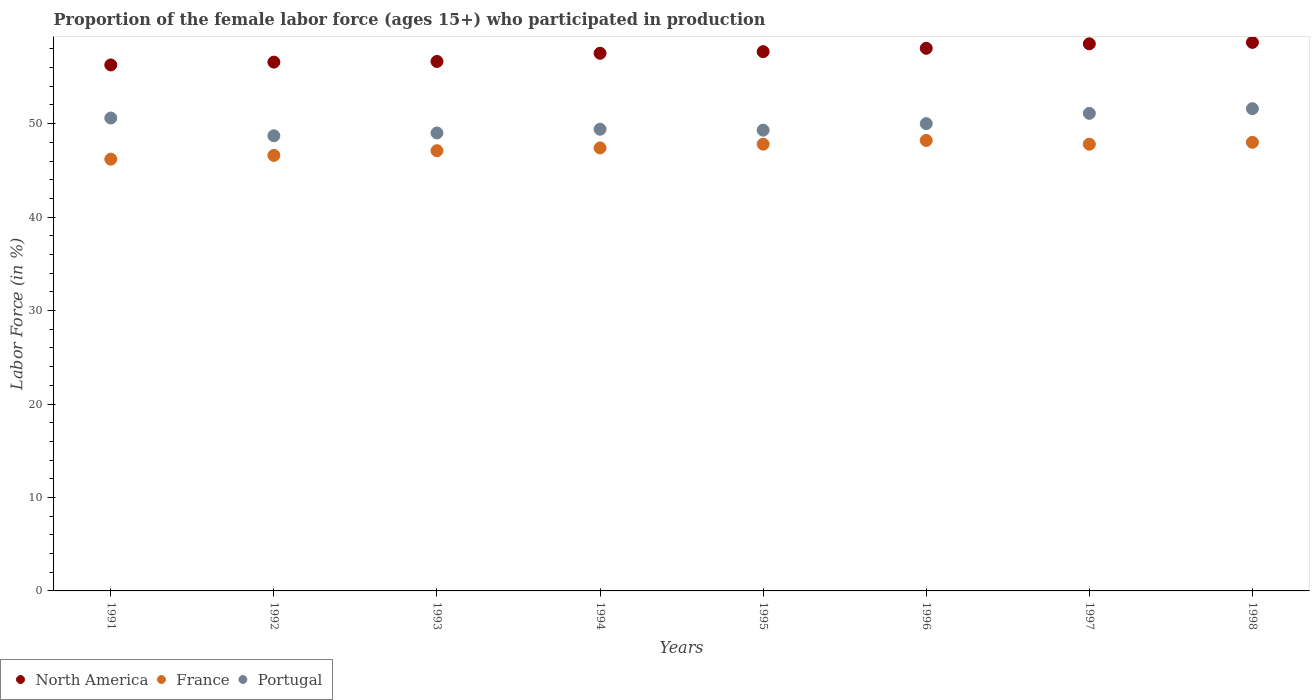How many different coloured dotlines are there?
Offer a very short reply. 3. What is the proportion of the female labor force who participated in production in Portugal in 1994?
Your response must be concise. 49.4. Across all years, what is the maximum proportion of the female labor force who participated in production in France?
Ensure brevity in your answer.  48.2. Across all years, what is the minimum proportion of the female labor force who participated in production in North America?
Your answer should be very brief. 56.28. In which year was the proportion of the female labor force who participated in production in North America maximum?
Provide a succinct answer. 1998. In which year was the proportion of the female labor force who participated in production in Portugal minimum?
Offer a terse response. 1992. What is the total proportion of the female labor force who participated in production in North America in the graph?
Provide a short and direct response. 460.03. What is the difference between the proportion of the female labor force who participated in production in Portugal in 1992 and that in 1997?
Offer a terse response. -2.4. What is the difference between the proportion of the female labor force who participated in production in Portugal in 1994 and the proportion of the female labor force who participated in production in France in 1997?
Your answer should be very brief. 1.6. What is the average proportion of the female labor force who participated in production in France per year?
Your answer should be very brief. 47.39. In the year 1997, what is the difference between the proportion of the female labor force who participated in production in North America and proportion of the female labor force who participated in production in Portugal?
Offer a very short reply. 7.44. In how many years, is the proportion of the female labor force who participated in production in North America greater than 14 %?
Your answer should be very brief. 8. What is the ratio of the proportion of the female labor force who participated in production in Portugal in 1991 to that in 1992?
Provide a short and direct response. 1.04. Is the proportion of the female labor force who participated in production in France in 1992 less than that in 1993?
Offer a terse response. Yes. What is the difference between the highest and the lowest proportion of the female labor force who participated in production in Portugal?
Give a very brief answer. 2.9. Is the sum of the proportion of the female labor force who participated in production in France in 1993 and 1997 greater than the maximum proportion of the female labor force who participated in production in Portugal across all years?
Keep it short and to the point. Yes. Is it the case that in every year, the sum of the proportion of the female labor force who participated in production in France and proportion of the female labor force who participated in production in Portugal  is greater than the proportion of the female labor force who participated in production in North America?
Offer a very short reply. Yes. Does the proportion of the female labor force who participated in production in Portugal monotonically increase over the years?
Keep it short and to the point. No. Is the proportion of the female labor force who participated in production in Portugal strictly less than the proportion of the female labor force who participated in production in France over the years?
Keep it short and to the point. No. How many dotlines are there?
Keep it short and to the point. 3. How many years are there in the graph?
Offer a terse response. 8. What is the difference between two consecutive major ticks on the Y-axis?
Keep it short and to the point. 10. Are the values on the major ticks of Y-axis written in scientific E-notation?
Make the answer very short. No. Does the graph contain any zero values?
Give a very brief answer. No. What is the title of the graph?
Offer a terse response. Proportion of the female labor force (ages 15+) who participated in production. What is the label or title of the Y-axis?
Offer a very short reply. Labor Force (in %). What is the Labor Force (in %) in North America in 1991?
Give a very brief answer. 56.28. What is the Labor Force (in %) of France in 1991?
Provide a short and direct response. 46.2. What is the Labor Force (in %) in Portugal in 1991?
Keep it short and to the point. 50.6. What is the Labor Force (in %) in North America in 1992?
Provide a short and direct response. 56.58. What is the Labor Force (in %) of France in 1992?
Keep it short and to the point. 46.6. What is the Labor Force (in %) of Portugal in 1992?
Give a very brief answer. 48.7. What is the Labor Force (in %) in North America in 1993?
Offer a terse response. 56.65. What is the Labor Force (in %) of France in 1993?
Ensure brevity in your answer.  47.1. What is the Labor Force (in %) in Portugal in 1993?
Provide a succinct answer. 49. What is the Labor Force (in %) of North America in 1994?
Offer a terse response. 57.53. What is the Labor Force (in %) in France in 1994?
Your answer should be very brief. 47.4. What is the Labor Force (in %) of Portugal in 1994?
Offer a very short reply. 49.4. What is the Labor Force (in %) of North America in 1995?
Provide a succinct answer. 57.7. What is the Labor Force (in %) in France in 1995?
Ensure brevity in your answer.  47.8. What is the Labor Force (in %) of Portugal in 1995?
Your response must be concise. 49.3. What is the Labor Force (in %) in North America in 1996?
Make the answer very short. 58.06. What is the Labor Force (in %) of France in 1996?
Give a very brief answer. 48.2. What is the Labor Force (in %) in Portugal in 1996?
Make the answer very short. 50. What is the Labor Force (in %) of North America in 1997?
Your answer should be compact. 58.54. What is the Labor Force (in %) in France in 1997?
Offer a very short reply. 47.8. What is the Labor Force (in %) in Portugal in 1997?
Give a very brief answer. 51.1. What is the Labor Force (in %) in North America in 1998?
Make the answer very short. 58.69. What is the Labor Force (in %) in Portugal in 1998?
Your answer should be very brief. 51.6. Across all years, what is the maximum Labor Force (in %) of North America?
Provide a succinct answer. 58.69. Across all years, what is the maximum Labor Force (in %) in France?
Make the answer very short. 48.2. Across all years, what is the maximum Labor Force (in %) of Portugal?
Offer a terse response. 51.6. Across all years, what is the minimum Labor Force (in %) in North America?
Give a very brief answer. 56.28. Across all years, what is the minimum Labor Force (in %) of France?
Keep it short and to the point. 46.2. Across all years, what is the minimum Labor Force (in %) in Portugal?
Offer a very short reply. 48.7. What is the total Labor Force (in %) in North America in the graph?
Provide a short and direct response. 460.03. What is the total Labor Force (in %) of France in the graph?
Offer a terse response. 379.1. What is the total Labor Force (in %) of Portugal in the graph?
Your response must be concise. 399.7. What is the difference between the Labor Force (in %) of North America in 1991 and that in 1992?
Your response must be concise. -0.3. What is the difference between the Labor Force (in %) in Portugal in 1991 and that in 1992?
Give a very brief answer. 1.9. What is the difference between the Labor Force (in %) of North America in 1991 and that in 1993?
Ensure brevity in your answer.  -0.37. What is the difference between the Labor Force (in %) in France in 1991 and that in 1993?
Make the answer very short. -0.9. What is the difference between the Labor Force (in %) in North America in 1991 and that in 1994?
Ensure brevity in your answer.  -1.25. What is the difference between the Labor Force (in %) of France in 1991 and that in 1994?
Give a very brief answer. -1.2. What is the difference between the Labor Force (in %) in Portugal in 1991 and that in 1994?
Offer a terse response. 1.2. What is the difference between the Labor Force (in %) in North America in 1991 and that in 1995?
Give a very brief answer. -1.42. What is the difference between the Labor Force (in %) of France in 1991 and that in 1995?
Provide a succinct answer. -1.6. What is the difference between the Labor Force (in %) of North America in 1991 and that in 1996?
Make the answer very short. -1.78. What is the difference between the Labor Force (in %) of France in 1991 and that in 1996?
Ensure brevity in your answer.  -2. What is the difference between the Labor Force (in %) in North America in 1991 and that in 1997?
Provide a succinct answer. -2.26. What is the difference between the Labor Force (in %) in North America in 1991 and that in 1998?
Your response must be concise. -2.41. What is the difference between the Labor Force (in %) of France in 1991 and that in 1998?
Give a very brief answer. -1.8. What is the difference between the Labor Force (in %) of North America in 1992 and that in 1993?
Make the answer very short. -0.07. What is the difference between the Labor Force (in %) of Portugal in 1992 and that in 1993?
Make the answer very short. -0.3. What is the difference between the Labor Force (in %) of North America in 1992 and that in 1994?
Offer a terse response. -0.95. What is the difference between the Labor Force (in %) of France in 1992 and that in 1994?
Keep it short and to the point. -0.8. What is the difference between the Labor Force (in %) of North America in 1992 and that in 1995?
Make the answer very short. -1.12. What is the difference between the Labor Force (in %) of France in 1992 and that in 1995?
Give a very brief answer. -1.2. What is the difference between the Labor Force (in %) in North America in 1992 and that in 1996?
Keep it short and to the point. -1.48. What is the difference between the Labor Force (in %) in France in 1992 and that in 1996?
Your answer should be very brief. -1.6. What is the difference between the Labor Force (in %) in Portugal in 1992 and that in 1996?
Ensure brevity in your answer.  -1.3. What is the difference between the Labor Force (in %) of North America in 1992 and that in 1997?
Offer a terse response. -1.96. What is the difference between the Labor Force (in %) in North America in 1992 and that in 1998?
Ensure brevity in your answer.  -2.11. What is the difference between the Labor Force (in %) in Portugal in 1992 and that in 1998?
Make the answer very short. -2.9. What is the difference between the Labor Force (in %) in North America in 1993 and that in 1994?
Offer a very short reply. -0.88. What is the difference between the Labor Force (in %) of France in 1993 and that in 1994?
Your answer should be very brief. -0.3. What is the difference between the Labor Force (in %) of North America in 1993 and that in 1995?
Your answer should be very brief. -1.05. What is the difference between the Labor Force (in %) of North America in 1993 and that in 1996?
Make the answer very short. -1.41. What is the difference between the Labor Force (in %) of Portugal in 1993 and that in 1996?
Your answer should be very brief. -1. What is the difference between the Labor Force (in %) in North America in 1993 and that in 1997?
Make the answer very short. -1.89. What is the difference between the Labor Force (in %) in France in 1993 and that in 1997?
Ensure brevity in your answer.  -0.7. What is the difference between the Labor Force (in %) of North America in 1993 and that in 1998?
Offer a very short reply. -2.04. What is the difference between the Labor Force (in %) of North America in 1994 and that in 1995?
Keep it short and to the point. -0.17. What is the difference between the Labor Force (in %) of Portugal in 1994 and that in 1995?
Provide a short and direct response. 0.1. What is the difference between the Labor Force (in %) of North America in 1994 and that in 1996?
Offer a terse response. -0.53. What is the difference between the Labor Force (in %) of France in 1994 and that in 1996?
Ensure brevity in your answer.  -0.8. What is the difference between the Labor Force (in %) of Portugal in 1994 and that in 1996?
Offer a terse response. -0.6. What is the difference between the Labor Force (in %) in North America in 1994 and that in 1997?
Your answer should be compact. -1.01. What is the difference between the Labor Force (in %) of France in 1994 and that in 1997?
Provide a short and direct response. -0.4. What is the difference between the Labor Force (in %) of Portugal in 1994 and that in 1997?
Your answer should be compact. -1.7. What is the difference between the Labor Force (in %) of North America in 1994 and that in 1998?
Your answer should be compact. -1.16. What is the difference between the Labor Force (in %) of France in 1994 and that in 1998?
Make the answer very short. -0.6. What is the difference between the Labor Force (in %) in North America in 1995 and that in 1996?
Your answer should be very brief. -0.36. What is the difference between the Labor Force (in %) of North America in 1995 and that in 1997?
Provide a short and direct response. -0.84. What is the difference between the Labor Force (in %) in France in 1995 and that in 1997?
Provide a short and direct response. 0. What is the difference between the Labor Force (in %) in Portugal in 1995 and that in 1997?
Make the answer very short. -1.8. What is the difference between the Labor Force (in %) in North America in 1995 and that in 1998?
Ensure brevity in your answer.  -0.99. What is the difference between the Labor Force (in %) in North America in 1996 and that in 1997?
Make the answer very short. -0.48. What is the difference between the Labor Force (in %) of Portugal in 1996 and that in 1997?
Provide a succinct answer. -1.1. What is the difference between the Labor Force (in %) of North America in 1996 and that in 1998?
Ensure brevity in your answer.  -0.63. What is the difference between the Labor Force (in %) of Portugal in 1996 and that in 1998?
Provide a succinct answer. -1.6. What is the difference between the Labor Force (in %) of North America in 1997 and that in 1998?
Your answer should be compact. -0.15. What is the difference between the Labor Force (in %) in North America in 1991 and the Labor Force (in %) in France in 1992?
Offer a terse response. 9.68. What is the difference between the Labor Force (in %) in North America in 1991 and the Labor Force (in %) in Portugal in 1992?
Your response must be concise. 7.58. What is the difference between the Labor Force (in %) of North America in 1991 and the Labor Force (in %) of France in 1993?
Keep it short and to the point. 9.18. What is the difference between the Labor Force (in %) in North America in 1991 and the Labor Force (in %) in Portugal in 1993?
Your response must be concise. 7.28. What is the difference between the Labor Force (in %) of North America in 1991 and the Labor Force (in %) of France in 1994?
Offer a terse response. 8.88. What is the difference between the Labor Force (in %) in North America in 1991 and the Labor Force (in %) in Portugal in 1994?
Your response must be concise. 6.88. What is the difference between the Labor Force (in %) of North America in 1991 and the Labor Force (in %) of France in 1995?
Provide a short and direct response. 8.48. What is the difference between the Labor Force (in %) in North America in 1991 and the Labor Force (in %) in Portugal in 1995?
Your response must be concise. 6.98. What is the difference between the Labor Force (in %) of North America in 1991 and the Labor Force (in %) of France in 1996?
Your answer should be very brief. 8.08. What is the difference between the Labor Force (in %) in North America in 1991 and the Labor Force (in %) in Portugal in 1996?
Your response must be concise. 6.28. What is the difference between the Labor Force (in %) in North America in 1991 and the Labor Force (in %) in France in 1997?
Offer a terse response. 8.48. What is the difference between the Labor Force (in %) in North America in 1991 and the Labor Force (in %) in Portugal in 1997?
Your answer should be very brief. 5.18. What is the difference between the Labor Force (in %) of North America in 1991 and the Labor Force (in %) of France in 1998?
Make the answer very short. 8.28. What is the difference between the Labor Force (in %) of North America in 1991 and the Labor Force (in %) of Portugal in 1998?
Make the answer very short. 4.68. What is the difference between the Labor Force (in %) of France in 1991 and the Labor Force (in %) of Portugal in 1998?
Offer a terse response. -5.4. What is the difference between the Labor Force (in %) of North America in 1992 and the Labor Force (in %) of France in 1993?
Offer a very short reply. 9.48. What is the difference between the Labor Force (in %) of North America in 1992 and the Labor Force (in %) of Portugal in 1993?
Give a very brief answer. 7.58. What is the difference between the Labor Force (in %) in France in 1992 and the Labor Force (in %) in Portugal in 1993?
Provide a succinct answer. -2.4. What is the difference between the Labor Force (in %) in North America in 1992 and the Labor Force (in %) in France in 1994?
Give a very brief answer. 9.18. What is the difference between the Labor Force (in %) of North America in 1992 and the Labor Force (in %) of Portugal in 1994?
Offer a very short reply. 7.18. What is the difference between the Labor Force (in %) of France in 1992 and the Labor Force (in %) of Portugal in 1994?
Give a very brief answer. -2.8. What is the difference between the Labor Force (in %) of North America in 1992 and the Labor Force (in %) of France in 1995?
Provide a short and direct response. 8.78. What is the difference between the Labor Force (in %) of North America in 1992 and the Labor Force (in %) of Portugal in 1995?
Provide a short and direct response. 7.28. What is the difference between the Labor Force (in %) of France in 1992 and the Labor Force (in %) of Portugal in 1995?
Keep it short and to the point. -2.7. What is the difference between the Labor Force (in %) of North America in 1992 and the Labor Force (in %) of France in 1996?
Your answer should be compact. 8.38. What is the difference between the Labor Force (in %) of North America in 1992 and the Labor Force (in %) of Portugal in 1996?
Ensure brevity in your answer.  6.58. What is the difference between the Labor Force (in %) in North America in 1992 and the Labor Force (in %) in France in 1997?
Your response must be concise. 8.78. What is the difference between the Labor Force (in %) of North America in 1992 and the Labor Force (in %) of Portugal in 1997?
Keep it short and to the point. 5.48. What is the difference between the Labor Force (in %) in France in 1992 and the Labor Force (in %) in Portugal in 1997?
Give a very brief answer. -4.5. What is the difference between the Labor Force (in %) of North America in 1992 and the Labor Force (in %) of France in 1998?
Offer a very short reply. 8.58. What is the difference between the Labor Force (in %) of North America in 1992 and the Labor Force (in %) of Portugal in 1998?
Your response must be concise. 4.98. What is the difference between the Labor Force (in %) of North America in 1993 and the Labor Force (in %) of France in 1994?
Make the answer very short. 9.25. What is the difference between the Labor Force (in %) in North America in 1993 and the Labor Force (in %) in Portugal in 1994?
Offer a very short reply. 7.25. What is the difference between the Labor Force (in %) in North America in 1993 and the Labor Force (in %) in France in 1995?
Your answer should be very brief. 8.85. What is the difference between the Labor Force (in %) of North America in 1993 and the Labor Force (in %) of Portugal in 1995?
Your response must be concise. 7.35. What is the difference between the Labor Force (in %) of France in 1993 and the Labor Force (in %) of Portugal in 1995?
Your answer should be compact. -2.2. What is the difference between the Labor Force (in %) of North America in 1993 and the Labor Force (in %) of France in 1996?
Offer a terse response. 8.45. What is the difference between the Labor Force (in %) in North America in 1993 and the Labor Force (in %) in Portugal in 1996?
Provide a short and direct response. 6.65. What is the difference between the Labor Force (in %) of France in 1993 and the Labor Force (in %) of Portugal in 1996?
Give a very brief answer. -2.9. What is the difference between the Labor Force (in %) of North America in 1993 and the Labor Force (in %) of France in 1997?
Offer a terse response. 8.85. What is the difference between the Labor Force (in %) in North America in 1993 and the Labor Force (in %) in Portugal in 1997?
Keep it short and to the point. 5.55. What is the difference between the Labor Force (in %) of France in 1993 and the Labor Force (in %) of Portugal in 1997?
Your answer should be very brief. -4. What is the difference between the Labor Force (in %) in North America in 1993 and the Labor Force (in %) in France in 1998?
Give a very brief answer. 8.65. What is the difference between the Labor Force (in %) in North America in 1993 and the Labor Force (in %) in Portugal in 1998?
Provide a succinct answer. 5.05. What is the difference between the Labor Force (in %) of France in 1993 and the Labor Force (in %) of Portugal in 1998?
Keep it short and to the point. -4.5. What is the difference between the Labor Force (in %) of North America in 1994 and the Labor Force (in %) of France in 1995?
Offer a very short reply. 9.73. What is the difference between the Labor Force (in %) in North America in 1994 and the Labor Force (in %) in Portugal in 1995?
Keep it short and to the point. 8.23. What is the difference between the Labor Force (in %) of France in 1994 and the Labor Force (in %) of Portugal in 1995?
Offer a terse response. -1.9. What is the difference between the Labor Force (in %) of North America in 1994 and the Labor Force (in %) of France in 1996?
Offer a very short reply. 9.33. What is the difference between the Labor Force (in %) of North America in 1994 and the Labor Force (in %) of Portugal in 1996?
Offer a very short reply. 7.53. What is the difference between the Labor Force (in %) of France in 1994 and the Labor Force (in %) of Portugal in 1996?
Give a very brief answer. -2.6. What is the difference between the Labor Force (in %) of North America in 1994 and the Labor Force (in %) of France in 1997?
Your answer should be very brief. 9.73. What is the difference between the Labor Force (in %) in North America in 1994 and the Labor Force (in %) in Portugal in 1997?
Give a very brief answer. 6.43. What is the difference between the Labor Force (in %) in North America in 1994 and the Labor Force (in %) in France in 1998?
Provide a succinct answer. 9.53. What is the difference between the Labor Force (in %) in North America in 1994 and the Labor Force (in %) in Portugal in 1998?
Offer a terse response. 5.93. What is the difference between the Labor Force (in %) of North America in 1995 and the Labor Force (in %) of France in 1996?
Make the answer very short. 9.5. What is the difference between the Labor Force (in %) of North America in 1995 and the Labor Force (in %) of Portugal in 1996?
Offer a very short reply. 7.7. What is the difference between the Labor Force (in %) of France in 1995 and the Labor Force (in %) of Portugal in 1996?
Offer a very short reply. -2.2. What is the difference between the Labor Force (in %) of North America in 1995 and the Labor Force (in %) of France in 1997?
Give a very brief answer. 9.9. What is the difference between the Labor Force (in %) in North America in 1995 and the Labor Force (in %) in Portugal in 1997?
Your answer should be compact. 6.6. What is the difference between the Labor Force (in %) in France in 1995 and the Labor Force (in %) in Portugal in 1997?
Ensure brevity in your answer.  -3.3. What is the difference between the Labor Force (in %) in North America in 1995 and the Labor Force (in %) in France in 1998?
Give a very brief answer. 9.7. What is the difference between the Labor Force (in %) of North America in 1995 and the Labor Force (in %) of Portugal in 1998?
Provide a succinct answer. 6.1. What is the difference between the Labor Force (in %) in France in 1995 and the Labor Force (in %) in Portugal in 1998?
Offer a terse response. -3.8. What is the difference between the Labor Force (in %) of North America in 1996 and the Labor Force (in %) of France in 1997?
Keep it short and to the point. 10.26. What is the difference between the Labor Force (in %) of North America in 1996 and the Labor Force (in %) of Portugal in 1997?
Provide a succinct answer. 6.96. What is the difference between the Labor Force (in %) in North America in 1996 and the Labor Force (in %) in France in 1998?
Offer a very short reply. 10.06. What is the difference between the Labor Force (in %) of North America in 1996 and the Labor Force (in %) of Portugal in 1998?
Your answer should be compact. 6.46. What is the difference between the Labor Force (in %) of France in 1996 and the Labor Force (in %) of Portugal in 1998?
Your answer should be compact. -3.4. What is the difference between the Labor Force (in %) in North America in 1997 and the Labor Force (in %) in France in 1998?
Your response must be concise. 10.54. What is the difference between the Labor Force (in %) in North America in 1997 and the Labor Force (in %) in Portugal in 1998?
Make the answer very short. 6.94. What is the average Labor Force (in %) in North America per year?
Keep it short and to the point. 57.5. What is the average Labor Force (in %) of France per year?
Keep it short and to the point. 47.39. What is the average Labor Force (in %) of Portugal per year?
Your answer should be very brief. 49.96. In the year 1991, what is the difference between the Labor Force (in %) in North America and Labor Force (in %) in France?
Your response must be concise. 10.08. In the year 1991, what is the difference between the Labor Force (in %) in North America and Labor Force (in %) in Portugal?
Give a very brief answer. 5.68. In the year 1992, what is the difference between the Labor Force (in %) in North America and Labor Force (in %) in France?
Offer a very short reply. 9.98. In the year 1992, what is the difference between the Labor Force (in %) in North America and Labor Force (in %) in Portugal?
Offer a very short reply. 7.88. In the year 1992, what is the difference between the Labor Force (in %) of France and Labor Force (in %) of Portugal?
Your answer should be compact. -2.1. In the year 1993, what is the difference between the Labor Force (in %) of North America and Labor Force (in %) of France?
Offer a terse response. 9.55. In the year 1993, what is the difference between the Labor Force (in %) in North America and Labor Force (in %) in Portugal?
Offer a terse response. 7.65. In the year 1994, what is the difference between the Labor Force (in %) in North America and Labor Force (in %) in France?
Your response must be concise. 10.13. In the year 1994, what is the difference between the Labor Force (in %) of North America and Labor Force (in %) of Portugal?
Provide a short and direct response. 8.13. In the year 1995, what is the difference between the Labor Force (in %) of North America and Labor Force (in %) of France?
Give a very brief answer. 9.9. In the year 1995, what is the difference between the Labor Force (in %) in North America and Labor Force (in %) in Portugal?
Offer a terse response. 8.4. In the year 1996, what is the difference between the Labor Force (in %) of North America and Labor Force (in %) of France?
Your answer should be compact. 9.86. In the year 1996, what is the difference between the Labor Force (in %) of North America and Labor Force (in %) of Portugal?
Make the answer very short. 8.06. In the year 1997, what is the difference between the Labor Force (in %) in North America and Labor Force (in %) in France?
Offer a terse response. 10.74. In the year 1997, what is the difference between the Labor Force (in %) of North America and Labor Force (in %) of Portugal?
Your answer should be very brief. 7.44. In the year 1998, what is the difference between the Labor Force (in %) of North America and Labor Force (in %) of France?
Offer a very short reply. 10.69. In the year 1998, what is the difference between the Labor Force (in %) in North America and Labor Force (in %) in Portugal?
Ensure brevity in your answer.  7.09. In the year 1998, what is the difference between the Labor Force (in %) of France and Labor Force (in %) of Portugal?
Your response must be concise. -3.6. What is the ratio of the Labor Force (in %) in North America in 1991 to that in 1992?
Make the answer very short. 0.99. What is the ratio of the Labor Force (in %) in Portugal in 1991 to that in 1992?
Keep it short and to the point. 1.04. What is the ratio of the Labor Force (in %) of France in 1991 to that in 1993?
Provide a succinct answer. 0.98. What is the ratio of the Labor Force (in %) in Portugal in 1991 to that in 1993?
Your response must be concise. 1.03. What is the ratio of the Labor Force (in %) of North America in 1991 to that in 1994?
Ensure brevity in your answer.  0.98. What is the ratio of the Labor Force (in %) of France in 1991 to that in 1994?
Offer a terse response. 0.97. What is the ratio of the Labor Force (in %) of Portugal in 1991 to that in 1994?
Make the answer very short. 1.02. What is the ratio of the Labor Force (in %) of North America in 1991 to that in 1995?
Keep it short and to the point. 0.98. What is the ratio of the Labor Force (in %) in France in 1991 to that in 1995?
Make the answer very short. 0.97. What is the ratio of the Labor Force (in %) of Portugal in 1991 to that in 1995?
Make the answer very short. 1.03. What is the ratio of the Labor Force (in %) of North America in 1991 to that in 1996?
Keep it short and to the point. 0.97. What is the ratio of the Labor Force (in %) in France in 1991 to that in 1996?
Your answer should be very brief. 0.96. What is the ratio of the Labor Force (in %) of North America in 1991 to that in 1997?
Your answer should be compact. 0.96. What is the ratio of the Labor Force (in %) in France in 1991 to that in 1997?
Your response must be concise. 0.97. What is the ratio of the Labor Force (in %) of Portugal in 1991 to that in 1997?
Offer a very short reply. 0.99. What is the ratio of the Labor Force (in %) in North America in 1991 to that in 1998?
Your answer should be very brief. 0.96. What is the ratio of the Labor Force (in %) of France in 1991 to that in 1998?
Make the answer very short. 0.96. What is the ratio of the Labor Force (in %) of Portugal in 1991 to that in 1998?
Ensure brevity in your answer.  0.98. What is the ratio of the Labor Force (in %) of North America in 1992 to that in 1993?
Your answer should be very brief. 1. What is the ratio of the Labor Force (in %) of France in 1992 to that in 1993?
Ensure brevity in your answer.  0.99. What is the ratio of the Labor Force (in %) in North America in 1992 to that in 1994?
Your response must be concise. 0.98. What is the ratio of the Labor Force (in %) in France in 1992 to that in 1994?
Your answer should be compact. 0.98. What is the ratio of the Labor Force (in %) of Portugal in 1992 to that in 1994?
Keep it short and to the point. 0.99. What is the ratio of the Labor Force (in %) in North America in 1992 to that in 1995?
Your response must be concise. 0.98. What is the ratio of the Labor Force (in %) in France in 1992 to that in 1995?
Your answer should be very brief. 0.97. What is the ratio of the Labor Force (in %) in North America in 1992 to that in 1996?
Make the answer very short. 0.97. What is the ratio of the Labor Force (in %) of France in 1992 to that in 1996?
Provide a succinct answer. 0.97. What is the ratio of the Labor Force (in %) in Portugal in 1992 to that in 1996?
Offer a terse response. 0.97. What is the ratio of the Labor Force (in %) in North America in 1992 to that in 1997?
Keep it short and to the point. 0.97. What is the ratio of the Labor Force (in %) in France in 1992 to that in 1997?
Your response must be concise. 0.97. What is the ratio of the Labor Force (in %) of Portugal in 1992 to that in 1997?
Provide a succinct answer. 0.95. What is the ratio of the Labor Force (in %) in North America in 1992 to that in 1998?
Your response must be concise. 0.96. What is the ratio of the Labor Force (in %) in France in 1992 to that in 1998?
Ensure brevity in your answer.  0.97. What is the ratio of the Labor Force (in %) in Portugal in 1992 to that in 1998?
Provide a short and direct response. 0.94. What is the ratio of the Labor Force (in %) in North America in 1993 to that in 1994?
Keep it short and to the point. 0.98. What is the ratio of the Labor Force (in %) in North America in 1993 to that in 1995?
Provide a succinct answer. 0.98. What is the ratio of the Labor Force (in %) in France in 1993 to that in 1995?
Provide a succinct answer. 0.99. What is the ratio of the Labor Force (in %) of North America in 1993 to that in 1996?
Keep it short and to the point. 0.98. What is the ratio of the Labor Force (in %) in France in 1993 to that in 1996?
Give a very brief answer. 0.98. What is the ratio of the Labor Force (in %) in Portugal in 1993 to that in 1996?
Offer a very short reply. 0.98. What is the ratio of the Labor Force (in %) in France in 1993 to that in 1997?
Your answer should be very brief. 0.99. What is the ratio of the Labor Force (in %) of Portugal in 1993 to that in 1997?
Give a very brief answer. 0.96. What is the ratio of the Labor Force (in %) of North America in 1993 to that in 1998?
Your answer should be very brief. 0.97. What is the ratio of the Labor Force (in %) in France in 1993 to that in 1998?
Your answer should be compact. 0.98. What is the ratio of the Labor Force (in %) of Portugal in 1993 to that in 1998?
Give a very brief answer. 0.95. What is the ratio of the Labor Force (in %) in France in 1994 to that in 1995?
Offer a terse response. 0.99. What is the ratio of the Labor Force (in %) in North America in 1994 to that in 1996?
Give a very brief answer. 0.99. What is the ratio of the Labor Force (in %) in France in 1994 to that in 1996?
Your response must be concise. 0.98. What is the ratio of the Labor Force (in %) of North America in 1994 to that in 1997?
Make the answer very short. 0.98. What is the ratio of the Labor Force (in %) in France in 1994 to that in 1997?
Your answer should be very brief. 0.99. What is the ratio of the Labor Force (in %) in Portugal in 1994 to that in 1997?
Your answer should be compact. 0.97. What is the ratio of the Labor Force (in %) in North America in 1994 to that in 1998?
Your answer should be compact. 0.98. What is the ratio of the Labor Force (in %) of France in 1994 to that in 1998?
Provide a short and direct response. 0.99. What is the ratio of the Labor Force (in %) in Portugal in 1994 to that in 1998?
Offer a terse response. 0.96. What is the ratio of the Labor Force (in %) of North America in 1995 to that in 1996?
Make the answer very short. 0.99. What is the ratio of the Labor Force (in %) of North America in 1995 to that in 1997?
Your response must be concise. 0.99. What is the ratio of the Labor Force (in %) of France in 1995 to that in 1997?
Ensure brevity in your answer.  1. What is the ratio of the Labor Force (in %) of Portugal in 1995 to that in 1997?
Offer a very short reply. 0.96. What is the ratio of the Labor Force (in %) in North America in 1995 to that in 1998?
Provide a short and direct response. 0.98. What is the ratio of the Labor Force (in %) in Portugal in 1995 to that in 1998?
Keep it short and to the point. 0.96. What is the ratio of the Labor Force (in %) of North America in 1996 to that in 1997?
Provide a short and direct response. 0.99. What is the ratio of the Labor Force (in %) in France in 1996 to that in 1997?
Give a very brief answer. 1.01. What is the ratio of the Labor Force (in %) in Portugal in 1996 to that in 1997?
Your response must be concise. 0.98. What is the ratio of the Labor Force (in %) of North America in 1996 to that in 1998?
Offer a terse response. 0.99. What is the ratio of the Labor Force (in %) in Portugal in 1996 to that in 1998?
Offer a very short reply. 0.97. What is the ratio of the Labor Force (in %) of France in 1997 to that in 1998?
Provide a short and direct response. 1. What is the ratio of the Labor Force (in %) in Portugal in 1997 to that in 1998?
Keep it short and to the point. 0.99. What is the difference between the highest and the second highest Labor Force (in %) in North America?
Provide a succinct answer. 0.15. What is the difference between the highest and the second highest Labor Force (in %) of France?
Provide a short and direct response. 0.2. What is the difference between the highest and the second highest Labor Force (in %) of Portugal?
Ensure brevity in your answer.  0.5. What is the difference between the highest and the lowest Labor Force (in %) in North America?
Keep it short and to the point. 2.41. What is the difference between the highest and the lowest Labor Force (in %) in France?
Your answer should be very brief. 2. What is the difference between the highest and the lowest Labor Force (in %) in Portugal?
Your answer should be compact. 2.9. 